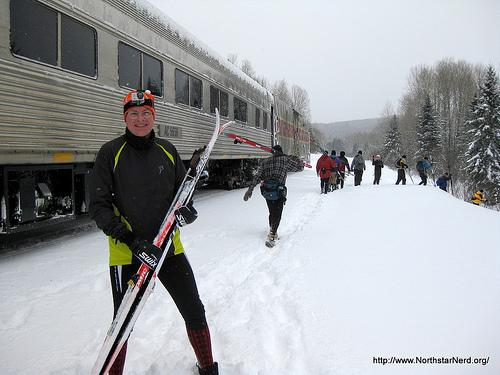For the visual entailment task, provide a statement about the train and determine if it is true, false, or uncertain. True Explain the current weather condition in the scene. The weather is cold and snowy with a gray overcast sky and white clouds scattered across the blue sky. Which type of trees are covered with snow in the image? Evergreen and pine trees are covered with snow. As an advertiser, create a short but catchy description of the scene that might be used for a skiing ad. Discover the winter wonderland! Join fellow adventurers skiing down snow-covered hills amidst breathtaking views of evergreens and mountain trains. For the multi-choice VQA task, identify the correct statement from the following options: D. All the people in the image are carrying snowboards. In a single sentence, describe the most visually dominant group of people in the image. A group of people in various colorful attire are walking in a line down a snow-covered hill, some carrying skis. What color is the hat of the person with a GoPro camera on their head? The hat is orange. What type of camouflage would blend perfectly with this scenery? A white and gray snowy camouflage pattern would blend perfectly with the scenery. For product advertisement, describe a potential skiing gear item that could be promoted using the image as the background. Introducing our new lightweight skis, designed for maximum performance and ease of use, perfect for traversing snowy hills and enjoying the stunning winter landscape. In the referential expression grounding task, provide a concise description of the person wearing a red outfit. A person in the group walking down the snowy hill is wearing red clothing. 